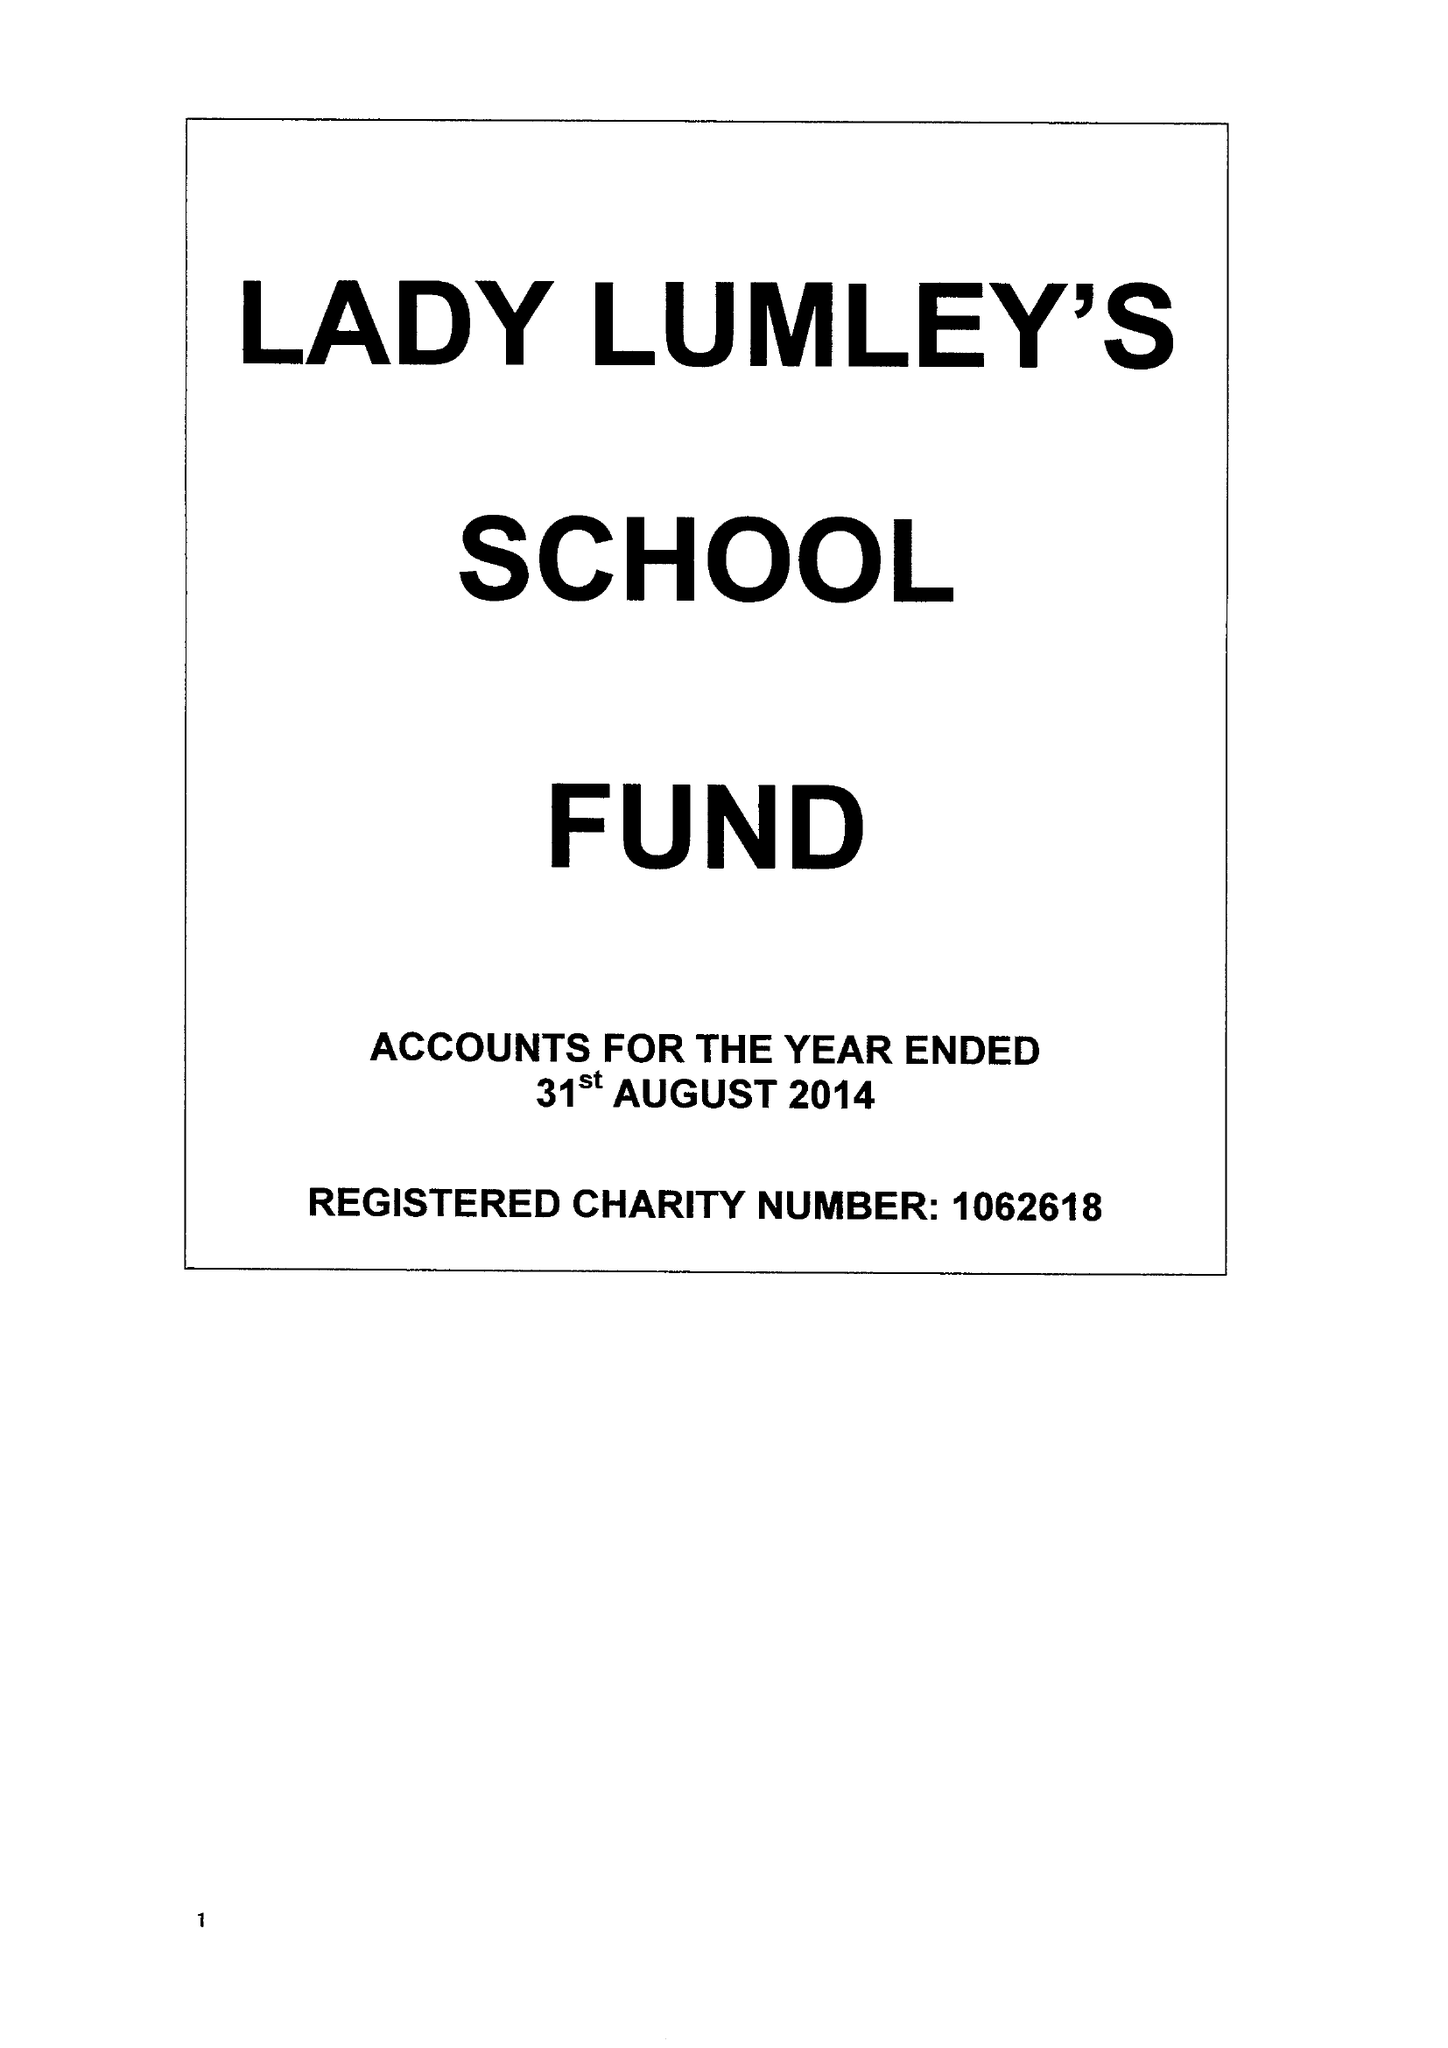What is the value for the address__postcode?
Answer the question using a single word or phrase. YO18 8NG 